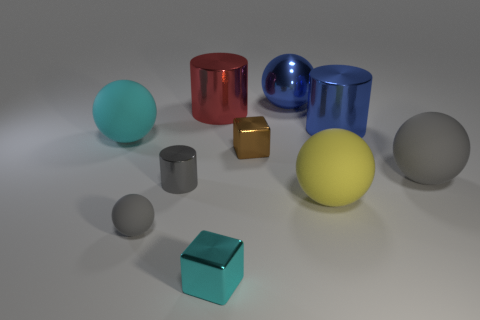Can you tell me the different materials that the objects seem to be made of? Certainly, the objects in the image suggest a range of materials: the spheres and cylinders have reflective surfaces hinting at metallic properties, while the cubes exhibit more matte finishes, suggesting perhaps a plastic or painted metal. Are there any patterns or consistencies in how the objects are arranged? The arrangement of objects doesn't show a deliberate pattern but presents a pleasing variety of shapes and colors, scattered in a manner that suggests a display rather than random placement. 